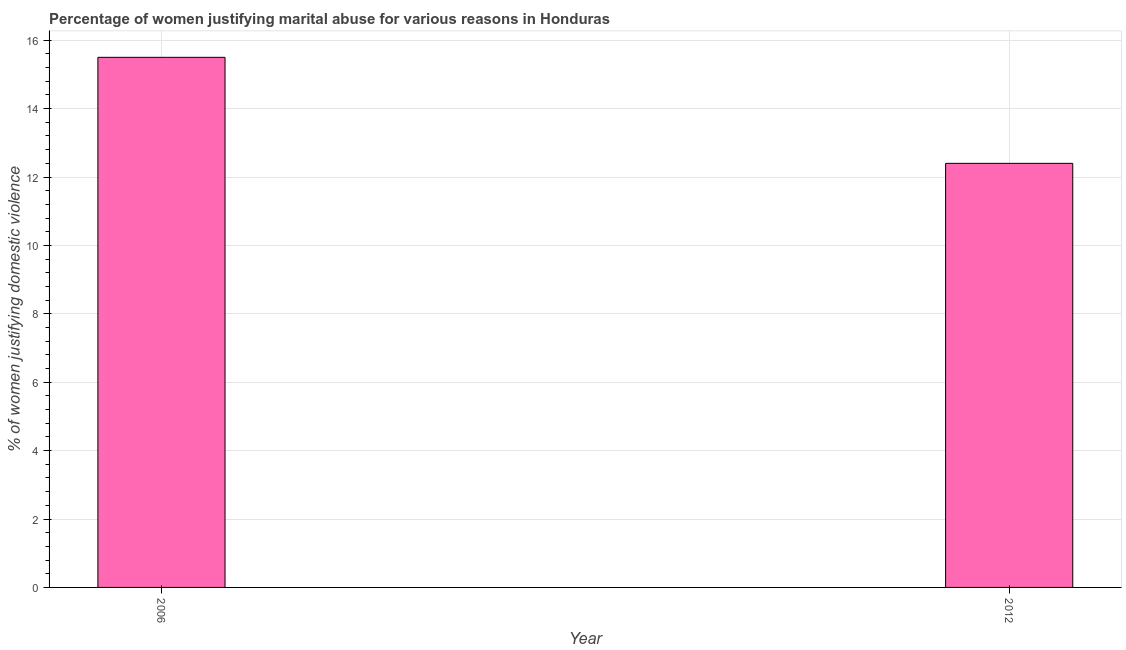Does the graph contain any zero values?
Ensure brevity in your answer.  No. What is the title of the graph?
Your answer should be very brief. Percentage of women justifying marital abuse for various reasons in Honduras. What is the label or title of the X-axis?
Keep it short and to the point. Year. What is the label or title of the Y-axis?
Provide a short and direct response. % of women justifying domestic violence. Across all years, what is the maximum percentage of women justifying marital abuse?
Offer a terse response. 15.5. Across all years, what is the minimum percentage of women justifying marital abuse?
Make the answer very short. 12.4. What is the sum of the percentage of women justifying marital abuse?
Keep it short and to the point. 27.9. What is the average percentage of women justifying marital abuse per year?
Offer a very short reply. 13.95. What is the median percentage of women justifying marital abuse?
Offer a very short reply. 13.95. In how many years, is the percentage of women justifying marital abuse greater than 11.2 %?
Make the answer very short. 2. What is the ratio of the percentage of women justifying marital abuse in 2006 to that in 2012?
Your answer should be compact. 1.25. What is the difference between two consecutive major ticks on the Y-axis?
Provide a short and direct response. 2. What is the % of women justifying domestic violence of 2012?
Your response must be concise. 12.4. What is the ratio of the % of women justifying domestic violence in 2006 to that in 2012?
Offer a terse response. 1.25. 